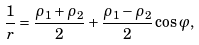<formula> <loc_0><loc_0><loc_500><loc_500>\frac { 1 } { r } = \frac { \rho _ { 1 } + \rho _ { 2 } } { 2 } + \frac { \rho _ { 1 } - \rho _ { 2 } } { 2 } \cos \varphi ,</formula> 